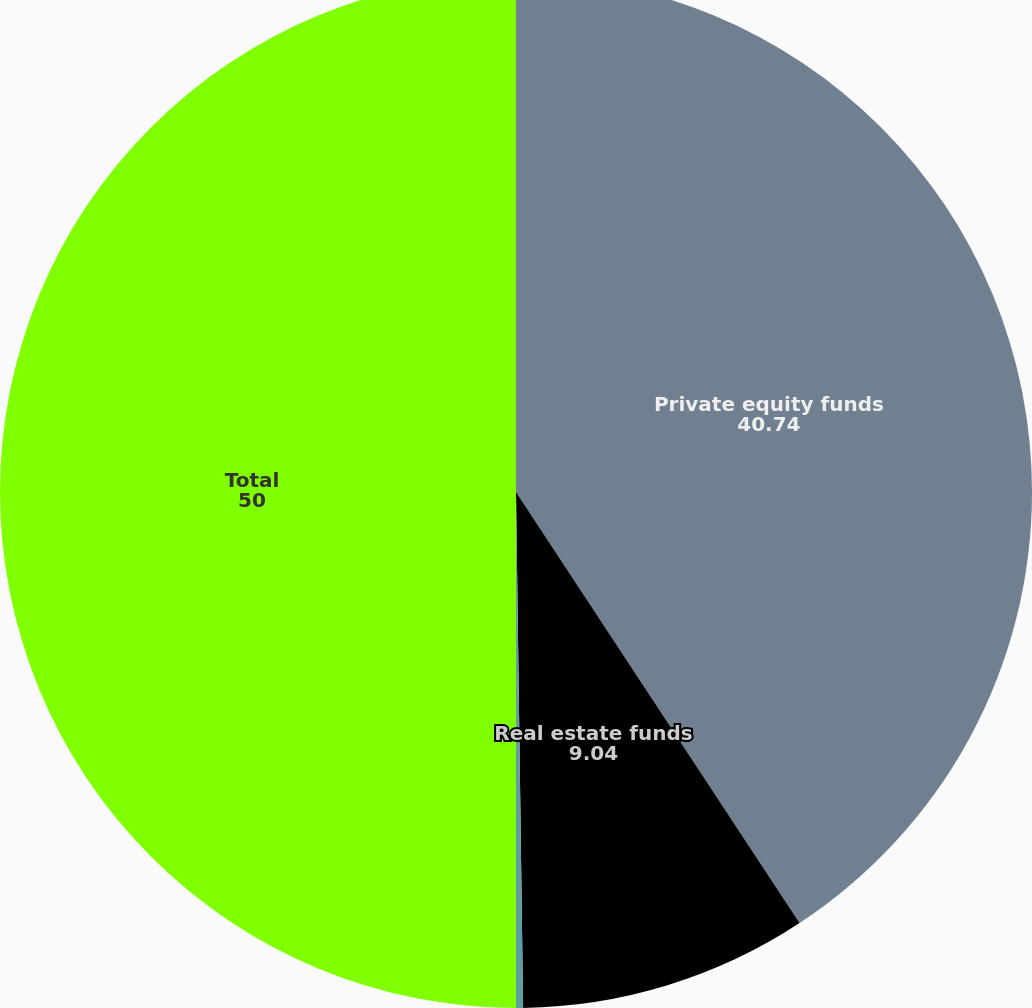<chart> <loc_0><loc_0><loc_500><loc_500><pie_chart><fcel>Private equity funds<fcel>Real estate funds<fcel>Multi-strategy hedge funds<fcel>Total<nl><fcel>40.74%<fcel>9.04%<fcel>0.22%<fcel>50.0%<nl></chart> 